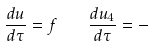<formula> <loc_0><loc_0><loc_500><loc_500>\frac { d u } { d \tau } = f \quad \frac { d u _ { 4 } } { d \tau } = -</formula> 